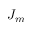<formula> <loc_0><loc_0><loc_500><loc_500>J _ { m }</formula> 